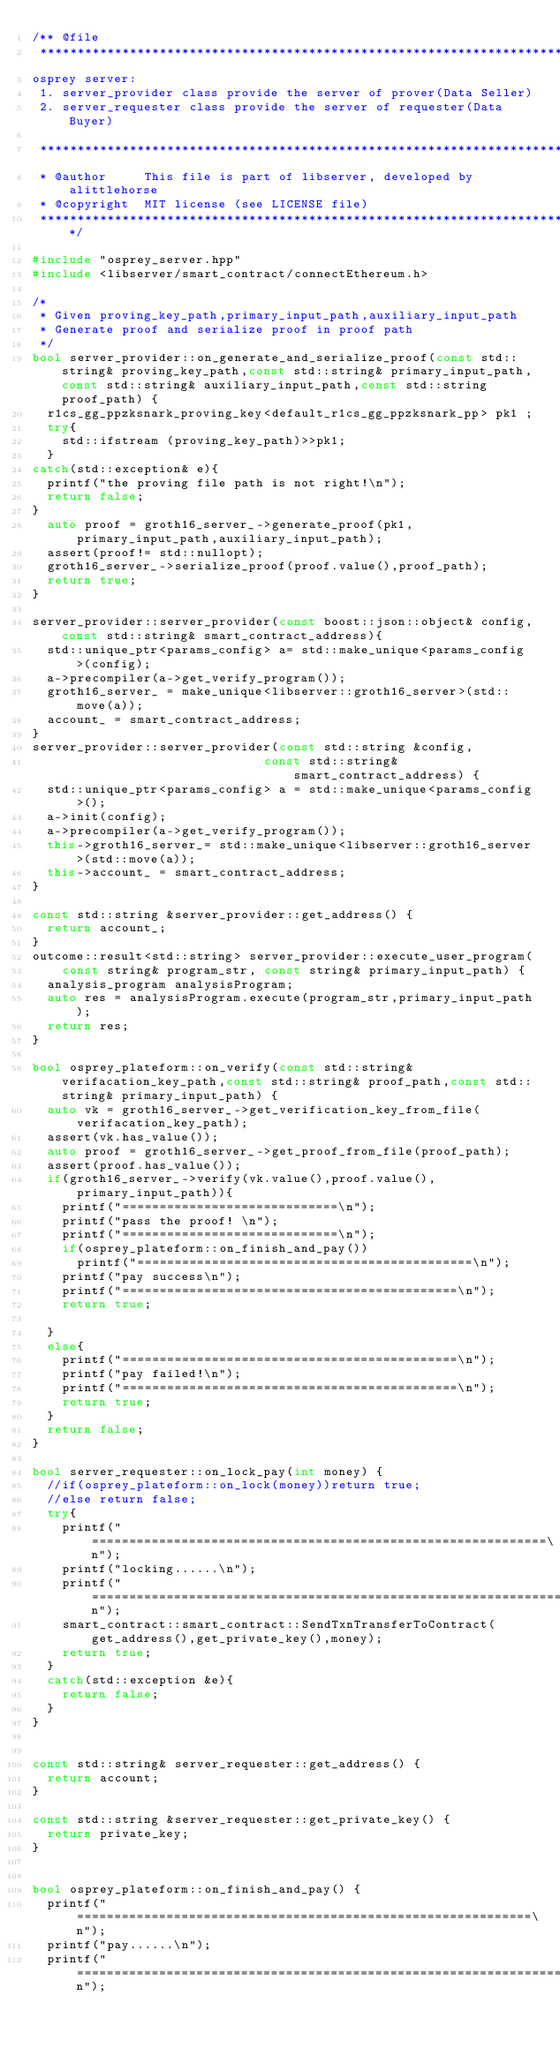<code> <loc_0><loc_0><loc_500><loc_500><_C++_>/** @file
 *****************************************************************************
osprey server:
 1. server_provider class provide the server of prover(Data Seller)
 2. server_requester class provide the server of requester(Data Buyer)

 *****************************************************************************
 * @author     This file is part of libserver, developed by alittlehorse
 * @copyright  MIT license (see LICENSE file)
 *****************************************************************************/

#include "osprey_server.hpp"
#include <libserver/smart_contract/connectEthereum.h>

/*
 * Given proving_key_path,primary_input_path,auxiliary_input_path
 * Generate proof and serialize proof in proof path
 */
bool server_provider::on_generate_and_serialize_proof(const std::string& proving_key_path,const std::string& primary_input_path,const std::string& auxiliary_input_path,const std::string proof_path) {
  r1cs_gg_ppzksnark_proving_key<default_r1cs_gg_ppzksnark_pp> pk1 ;
  try{
    std::ifstream (proving_key_path)>>pk1;
  }
catch(std::exception& e){
  printf("the proving file path is not right!\n");
  return false;
}
  auto proof = groth16_server_->generate_proof(pk1,primary_input_path,auxiliary_input_path);
  assert(proof!= std::nullopt);
  groth16_server_->serialize_proof(proof.value(),proof_path);
  return true;
}

server_provider::server_provider(const boost::json::object& config,const std::string& smart_contract_address){
  std::unique_ptr<params_config> a= std::make_unique<params_config>(config);
  a->precompiler(a->get_verify_program());
  groth16_server_ = make_unique<libserver::groth16_server>(std::move(a));
  account_ = smart_contract_address;
}
server_provider::server_provider(const std::string &config,
                               const std::string& smart_contract_address) {
  std::unique_ptr<params_config> a = std::make_unique<params_config>();
  a->init(config);
  a->precompiler(a->get_verify_program());
  this->groth16_server_= std::make_unique<libserver::groth16_server>(std::move(a));
  this->account_ = smart_contract_address;
}

const std::string &server_provider::get_address() {
  return account_;
}
outcome::result<std::string> server_provider::execute_user_program(
    const string& program_str, const string& primary_input_path) {
  analysis_program analysisProgram;
  auto res = analysisProgram.execute(program_str,primary_input_path);
  return res;
}

bool osprey_plateform::on_verify(const std::string& verifacation_key_path,const std::string& proof_path,const std::string& primary_input_path) {
  auto vk = groth16_server_->get_verification_key_from_file(verifacation_key_path);
  assert(vk.has_value());
  auto proof = groth16_server_->get_proof_from_file(proof_path);
  assert(proof.has_value());
  if(groth16_server_->verify(vk.value(),proof.value(),primary_input_path)){
    printf("=============================\n");
    printf("pass the proof! \n");
    printf("=============================\n");
    if(osprey_plateform::on_finish_and_pay())
      printf("=============================================\n");
    printf("pay success\n");
    printf("=============================================\n");
    return true;

  }
  else{
    printf("=============================================\n");
    printf("pay failed!\n");
    printf("=============================================\n");
    return true;
  }
  return false;
}

bool server_requester::on_lock_pay(int money) {
  //if(osprey_plateform::on_lock(money))return true;
  //else return false;
  try{
    printf("=============================================================\n");
    printf("locking......\n");
    printf("====================================================================\n");
    smart_contract::smart_contract::SendTxnTransferToContract(get_address(),get_private_key(),money);
    return true;
  }
  catch(std::exception &e){
    return false;
  }
}


const std::string& server_requester::get_address() {
  return account;
}

const std::string &server_requester::get_private_key() {
  return private_key;
}


bool osprey_plateform::on_finish_and_pay() {
  printf("=============================================================\n");
  printf("pay......\n");
  printf("====================================================================\n");</code> 